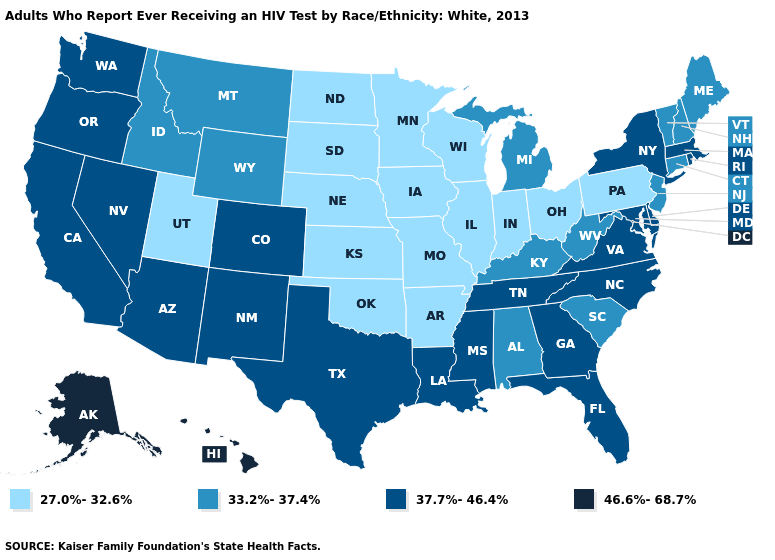Does the map have missing data?
Write a very short answer. No. Does Minnesota have the lowest value in the USA?
Keep it brief. Yes. What is the value of Maine?
Keep it brief. 33.2%-37.4%. Does Utah have the lowest value in the USA?
Give a very brief answer. Yes. What is the value of Florida?
Keep it brief. 37.7%-46.4%. What is the lowest value in states that border Rhode Island?
Keep it brief. 33.2%-37.4%. What is the value of Rhode Island?
Answer briefly. 37.7%-46.4%. Does Iowa have the highest value in the MidWest?
Answer briefly. No. Name the states that have a value in the range 46.6%-68.7%?
Concise answer only. Alaska, Hawaii. Name the states that have a value in the range 37.7%-46.4%?
Concise answer only. Arizona, California, Colorado, Delaware, Florida, Georgia, Louisiana, Maryland, Massachusetts, Mississippi, Nevada, New Mexico, New York, North Carolina, Oregon, Rhode Island, Tennessee, Texas, Virginia, Washington. What is the lowest value in the USA?
Quick response, please. 27.0%-32.6%. Name the states that have a value in the range 37.7%-46.4%?
Be succinct. Arizona, California, Colorado, Delaware, Florida, Georgia, Louisiana, Maryland, Massachusetts, Mississippi, Nevada, New Mexico, New York, North Carolina, Oregon, Rhode Island, Tennessee, Texas, Virginia, Washington. What is the value of South Carolina?
Concise answer only. 33.2%-37.4%. Among the states that border New York , does Massachusetts have the highest value?
Give a very brief answer. Yes. What is the value of Colorado?
Short answer required. 37.7%-46.4%. 